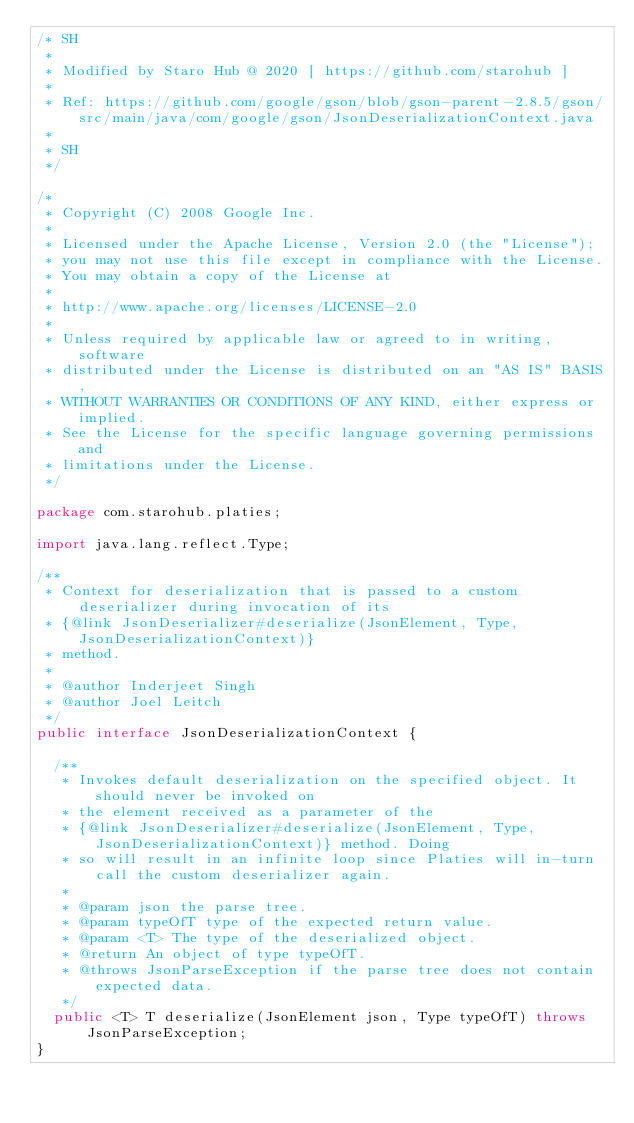<code> <loc_0><loc_0><loc_500><loc_500><_Java_>/* SH
 *
 * Modified by Staro Hub @ 2020 [ https://github.com/starohub ]
 *
 * Ref: https://github.com/google/gson/blob/gson-parent-2.8.5/gson/src/main/java/com/google/gson/JsonDeserializationContext.java
 *
 * SH
 */

/*
 * Copyright (C) 2008 Google Inc.
 *
 * Licensed under the Apache License, Version 2.0 (the "License");
 * you may not use this file except in compliance with the License.
 * You may obtain a copy of the License at
 *
 * http://www.apache.org/licenses/LICENSE-2.0
 *
 * Unless required by applicable law or agreed to in writing, software
 * distributed under the License is distributed on an "AS IS" BASIS,
 * WITHOUT WARRANTIES OR CONDITIONS OF ANY KIND, either express or implied.
 * See the License for the specific language governing permissions and
 * limitations under the License.
 */

package com.starohub.platies;

import java.lang.reflect.Type;

/**
 * Context for deserialization that is passed to a custom deserializer during invocation of its
 * {@link JsonDeserializer#deserialize(JsonElement, Type, JsonDeserializationContext)}
 * method.
 *
 * @author Inderjeet Singh
 * @author Joel Leitch
 */
public interface JsonDeserializationContext {

  /**
   * Invokes default deserialization on the specified object. It should never be invoked on
   * the element received as a parameter of the
   * {@link JsonDeserializer#deserialize(JsonElement, Type, JsonDeserializationContext)} method. Doing
   * so will result in an infinite loop since Platies will in-turn call the custom deserializer again.
   *
   * @param json the parse tree.
   * @param typeOfT type of the expected return value.
   * @param <T> The type of the deserialized object.
   * @return An object of type typeOfT.
   * @throws JsonParseException if the parse tree does not contain expected data.
   */
  public <T> T deserialize(JsonElement json, Type typeOfT) throws JsonParseException;
}</code> 